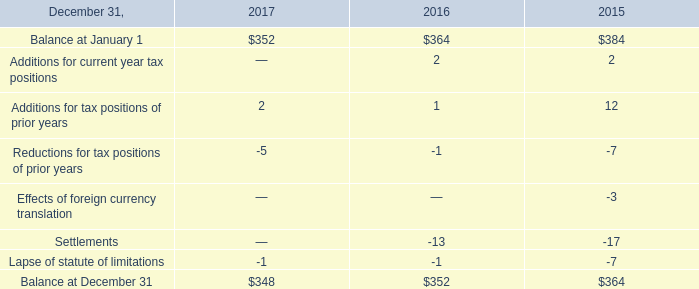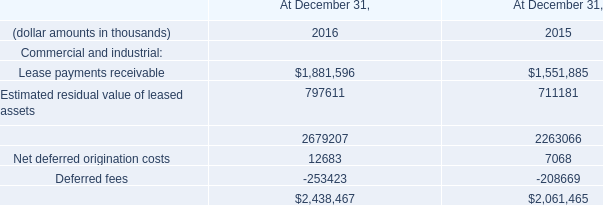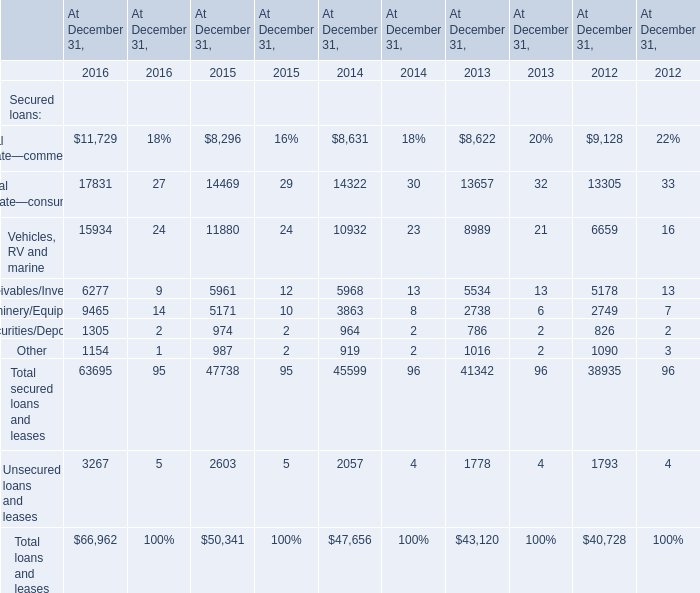What is the total amount of Lease payments receivable of At December 31, 2015, Real estate—commercial of At December 31, 2016, and Receivables/Inventory of At December 31, 2013 ? 
Computations: ((1551885.0 + 11729.0) + 5534.0)
Answer: 1569148.0. 